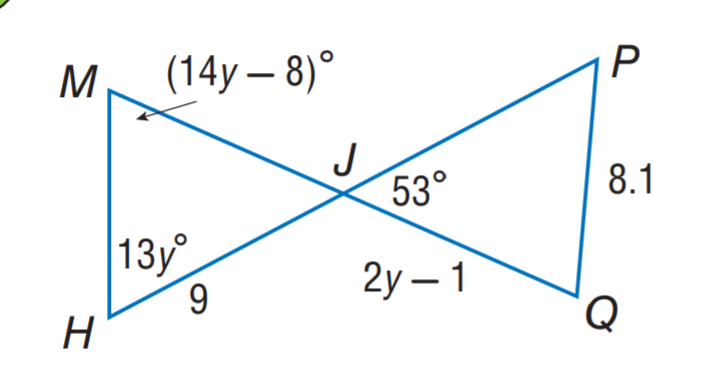Answer the mathemtical geometry problem and directly provide the correct option letter.
Question: \triangle M H J \cong \triangle P Q J. Find y.
Choices: A: 3 B: 4 C: 5 D: 6 C 